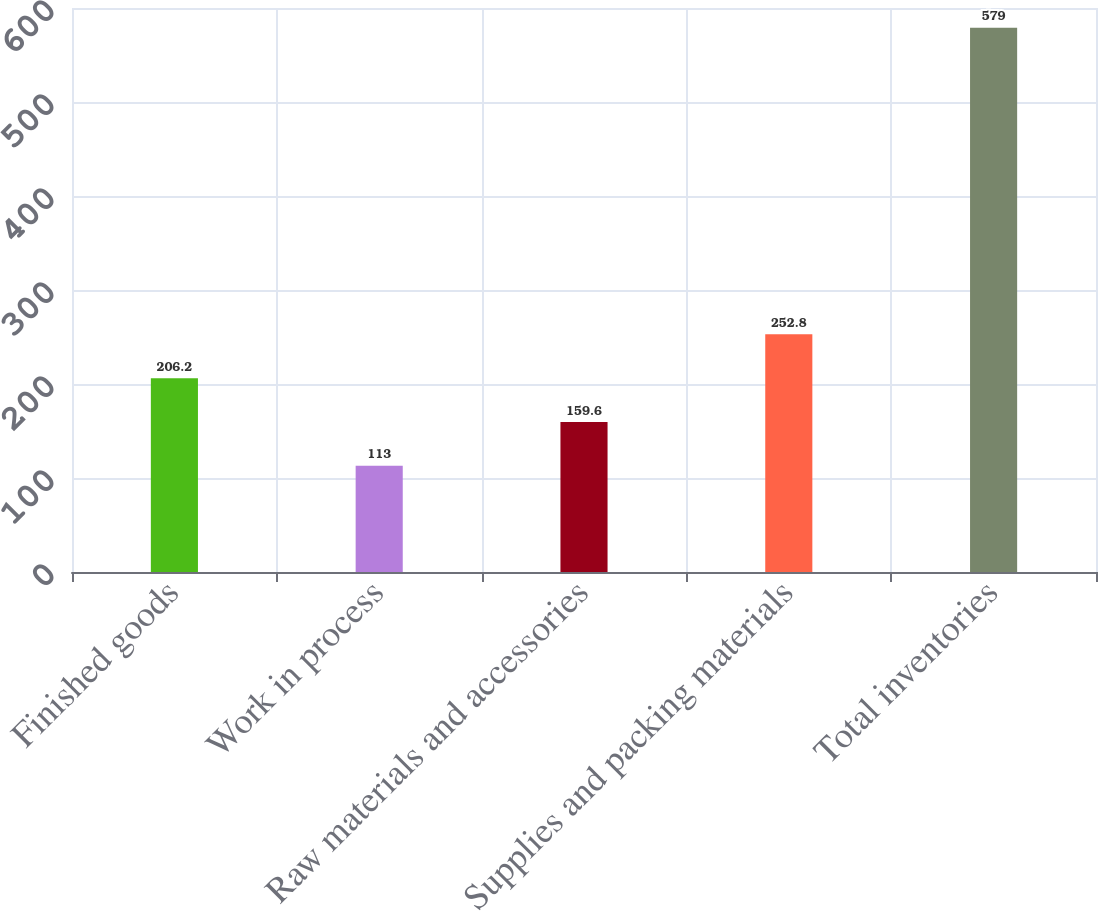Convert chart. <chart><loc_0><loc_0><loc_500><loc_500><bar_chart><fcel>Finished goods<fcel>Work in process<fcel>Raw materials and accessories<fcel>Supplies and packing materials<fcel>Total inventories<nl><fcel>206.2<fcel>113<fcel>159.6<fcel>252.8<fcel>579<nl></chart> 